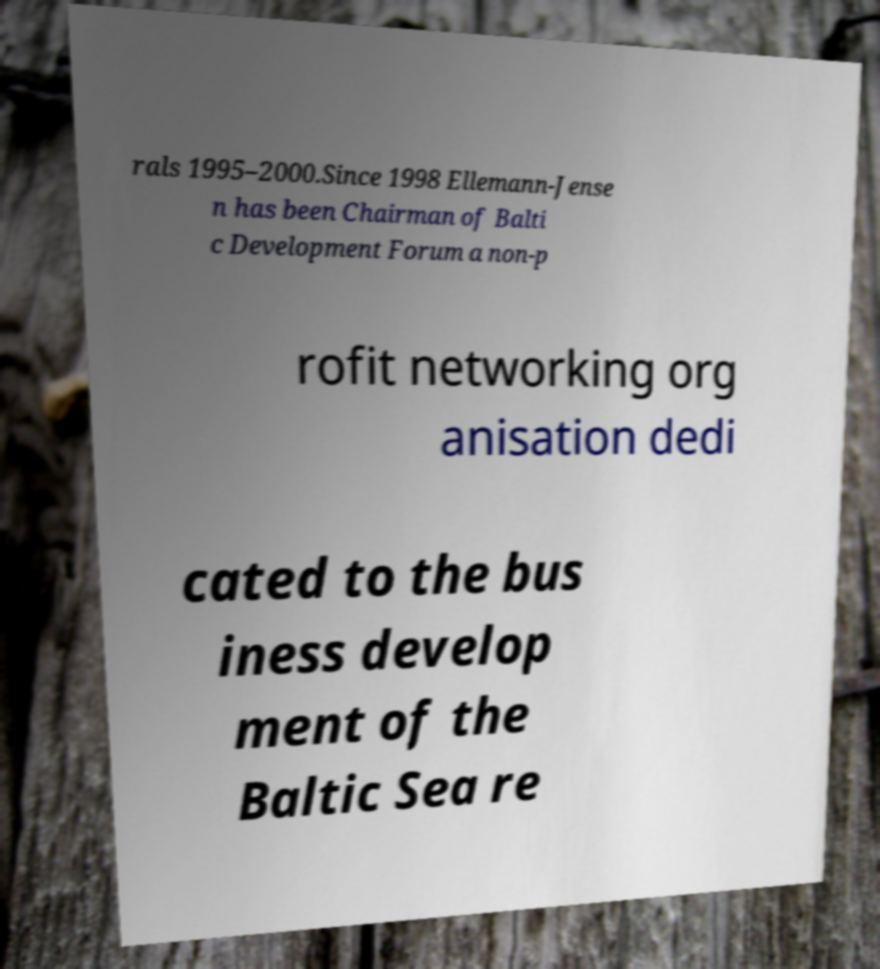Could you extract and type out the text from this image? rals 1995–2000.Since 1998 Ellemann-Jense n has been Chairman of Balti c Development Forum a non-p rofit networking org anisation dedi cated to the bus iness develop ment of the Baltic Sea re 